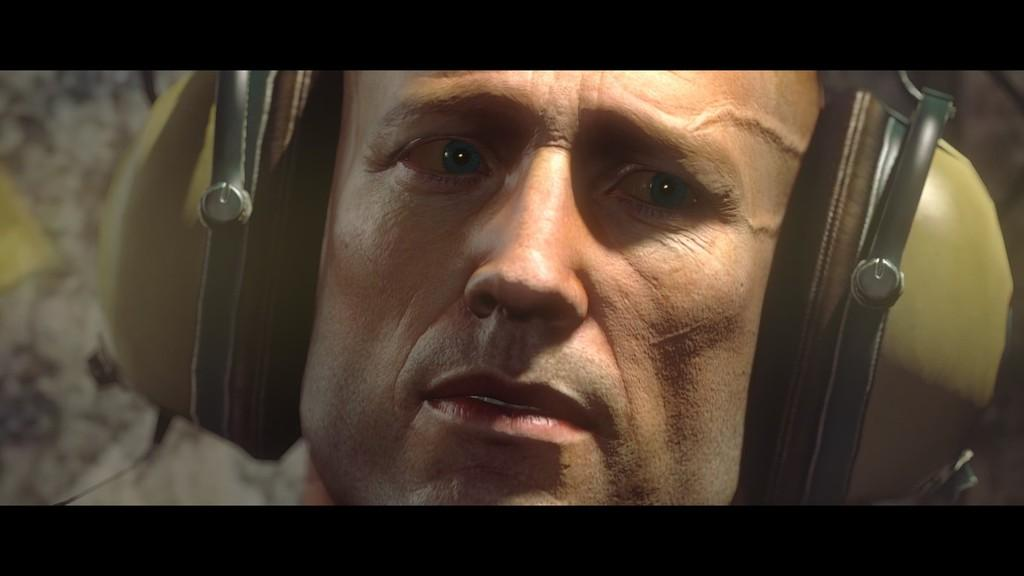What can be seen in the image? There is a person in the image. What is the person wearing? The person is wearing a headset. Can you describe the background of the image? The background of the image is blurred. What is the chance of the person winning the nerve competition in the image? There is no mention of a nerve competition or any competition in the image, so it is not possible to determine the chance of winning. 